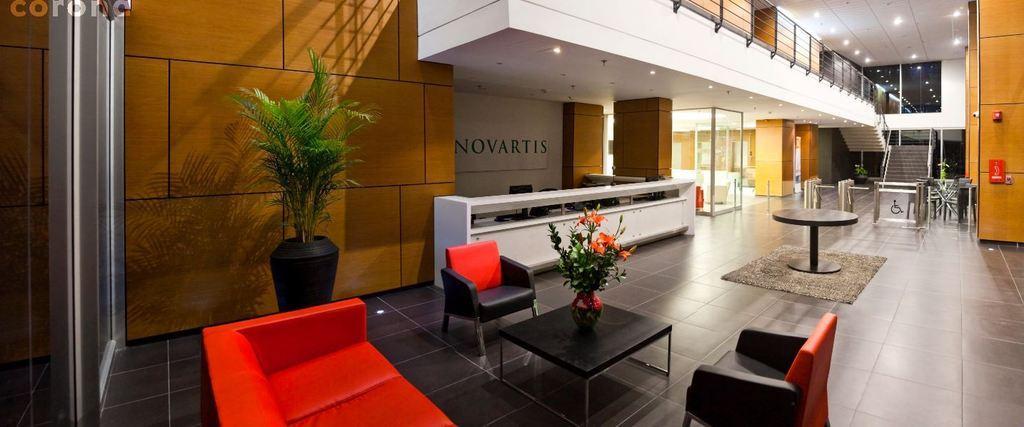In one or two sentences, can you explain what this image depicts? In this image there is a couch,table and a chair on the floor. There is a flower pot. At the background there are stairs and a glass door. 